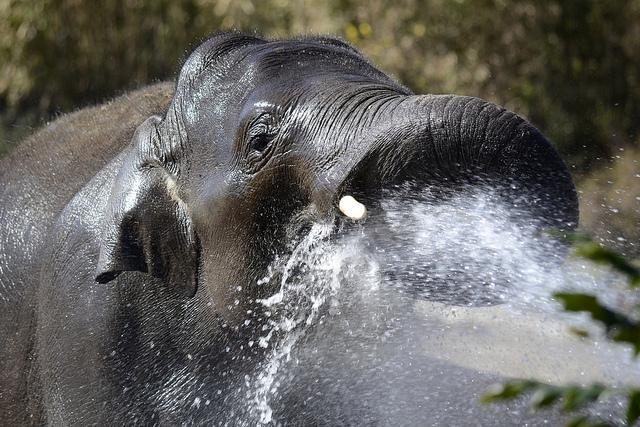What animal is this?
Write a very short answer. Elephant. What is in front of the animal?
Keep it brief. Water. Is the animal safe?
Quick response, please. Yes. 